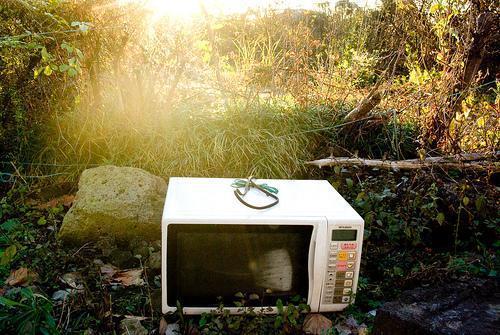How many appliances are shown?
Give a very brief answer. 1. 